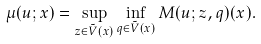<formula> <loc_0><loc_0><loc_500><loc_500>\mu ( u ; x ) = \sup _ { z \in \tilde { V } ( x ) } \inf _ { q \in \tilde { V } ( x ) } M ( u ; z , q ) ( x ) .</formula> 